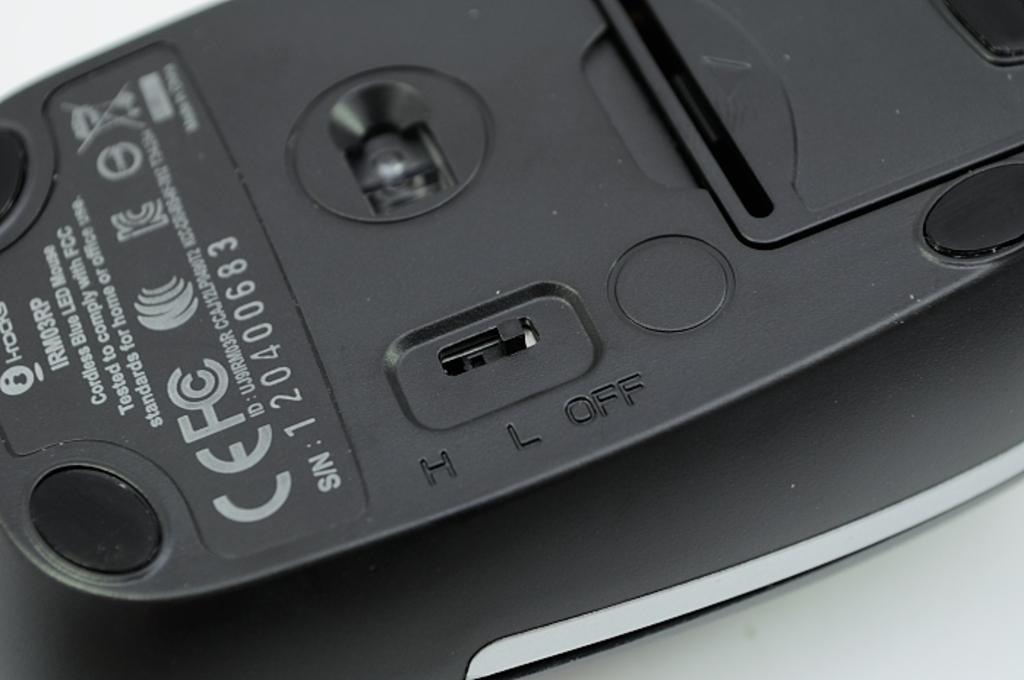What 3 letter word is engraved on the bottom of this mouse which appears after the letters h and l?
Your answer should be very brief. Off. 